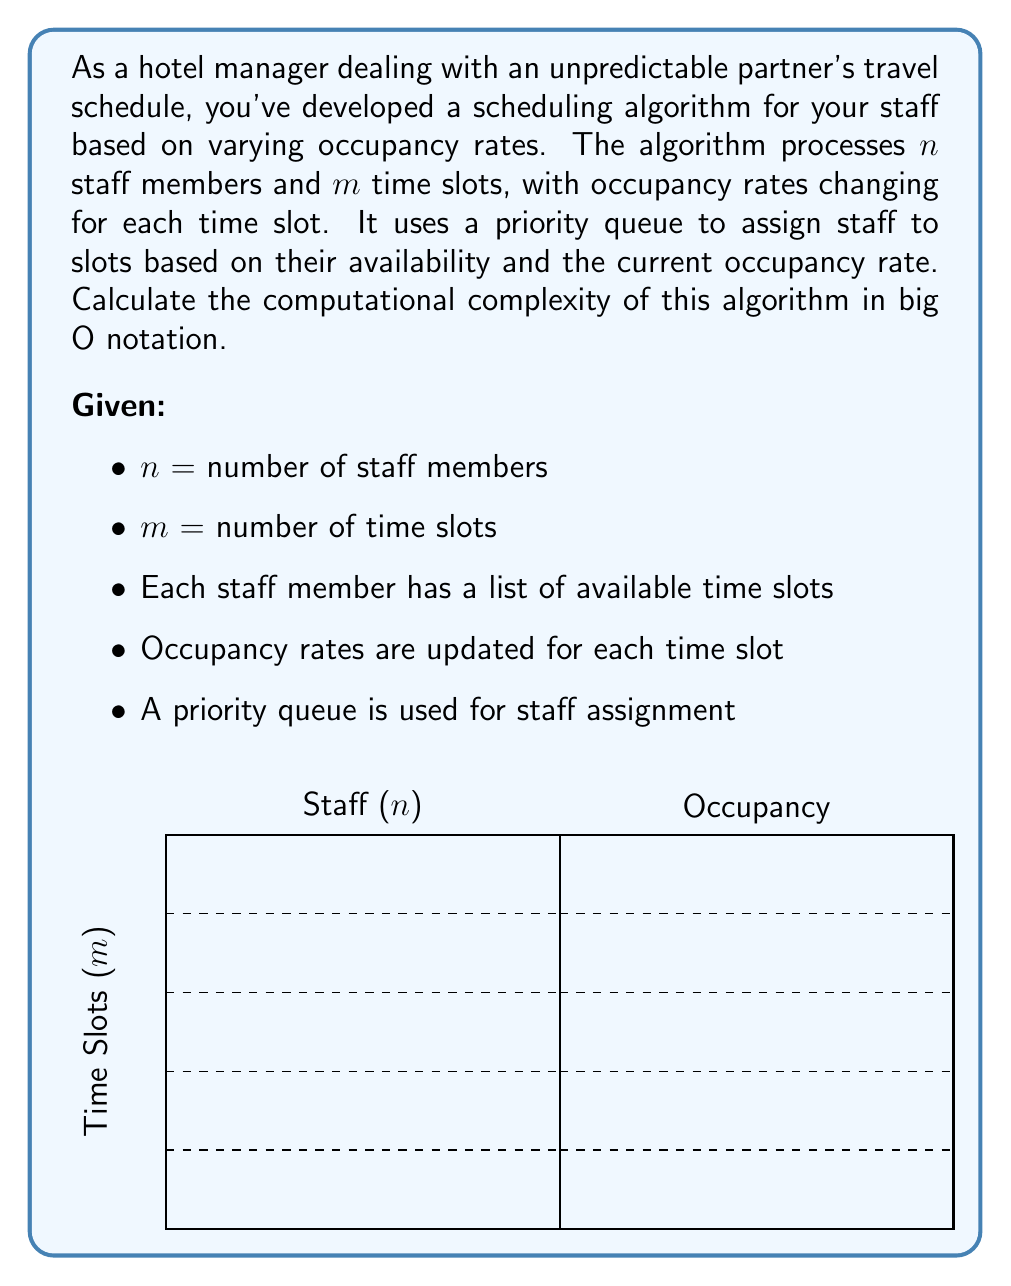Can you solve this math problem? To determine the computational complexity, let's break down the algorithm and analyze each step:

1. Initialization:
   - Creating a priority queue for $n$ staff members: $O(n)$
   - Initializing data structures for $m$ time slots: $O(m)$

2. Main loop (iterating through $m$ time slots):
   For each time slot:
   a. Update occupancy rate: $O(1)$
   b. Find available staff (worst case, check all $n$ staff): $O(n)$
   c. Add available staff to priority queue: $O(\log n)$ per staff member
      Worst case (all staff available): $O(n \log n)$
   d. Assign staff from priority queue: $O(\log n)$

3. Total complexity for main loop:
   $O(m \cdot (n + n \log n + \log n))$ = $O(m \cdot n \log n)$

4. Overall complexity:
   Initialization + Main loop
   $O(n + m + m \cdot n \log n)$

5. Simplifying:
   The dominant term is $O(m \cdot n \log n)$, as it grows faster than $O(n)$ and $O(m)$

Therefore, the computational complexity of the algorithm is $O(m \cdot n \log n)$.
Answer: $O(m \cdot n \log n)$ 